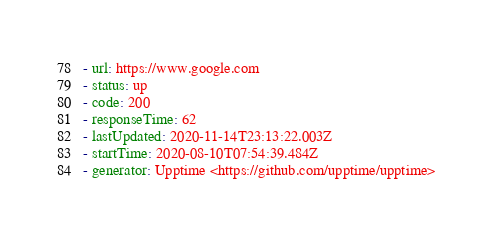Convert code to text. <code><loc_0><loc_0><loc_500><loc_500><_YAML_>- url: https://www.google.com
- status: up
- code: 200
- responseTime: 62
- lastUpdated: 2020-11-14T23:13:22.003Z
- startTime: 2020-08-10T07:54:39.484Z
- generator: Upptime <https://github.com/upptime/upptime>
</code> 